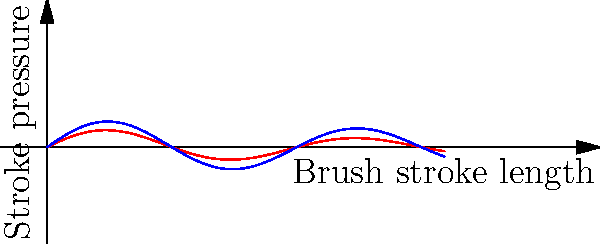As a long-time fan of Hannah Rosenbloom, you're aware that her unique brush stroke technique is often imitated. The graph shows the relationship between brush stroke length and pressure for an original Rosenbloom painting (red) and a suspected forgery (blue). Which mathematical property best distinguishes the original from the forgery? To determine the key difference between the original and the forgery, let's analyze the graph step-by-step:

1. Both curves show a sinusoidal pattern, which represents the artist's characteristic brush stroke technique.

2. The red curve (original) decays faster than the blue curve (forgery) as the stroke length increases.

3. This decay rate is determined by the exponential factor in the functions:
   - Original (red): $f(x) = 0.5e^{-0.1x}\sin(x)$
   - Forgery (blue): $g(x) = 0.7e^{-0.05x}\sin(x)$

4. The key difference is in the exponential decay rate:
   - Original: $-0.1x$ in the exponent
   - Forgery: $-0.05x$ in the exponent

5. The original has a larger negative coefficient in the exponent, causing it to decay more rapidly.

6. This faster decay rate in the original represents Hannah Rosenbloom's ability to maintain consistent pressure over shorter strokes but decrease pressure more quickly on longer strokes, a subtle technique that forgers often struggle to replicate accurately.

Therefore, the exponential decay rate is the key mathematical property that best distinguishes the original from the forgery.
Answer: Exponential decay rate 